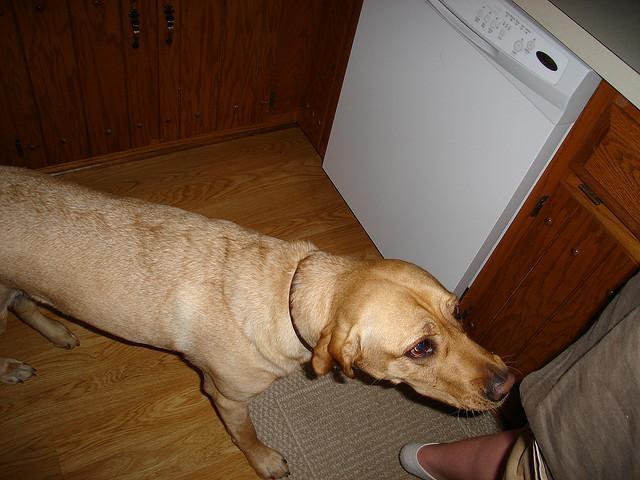How many signs are hanging above the toilet that are not written in english?
Give a very brief answer. 0. 